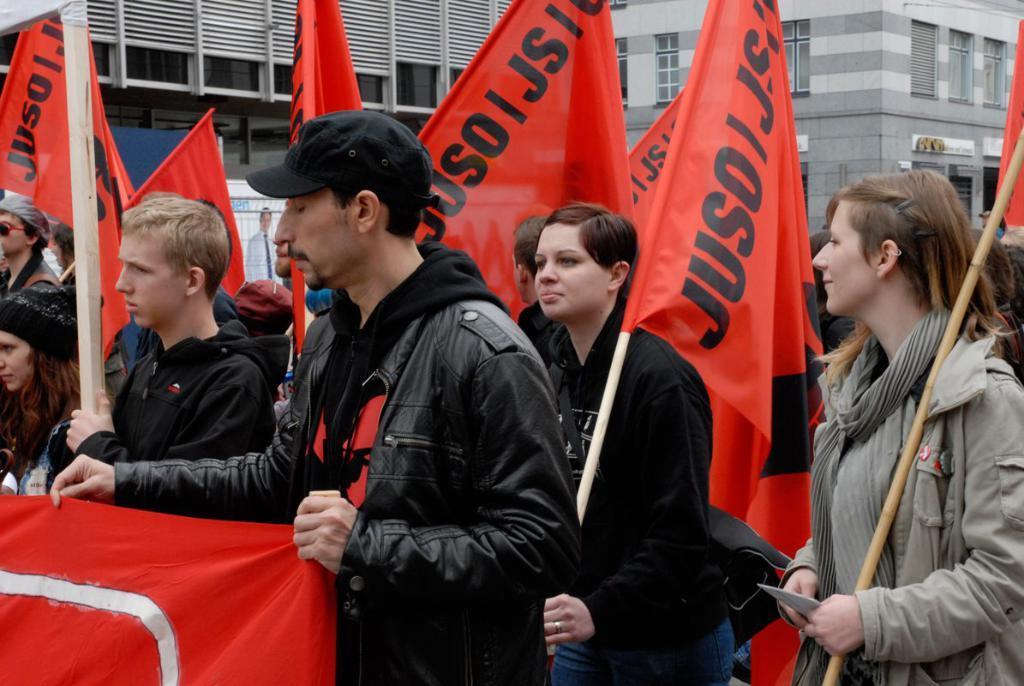Describe this image in one or two sentences. In this picture there is a man who is wearing cap, jacket, t-shirt and trouser. He is holding a red color cloth. On the right there are two women who are holding a flag. In the back we can see group of persons. On the top we can see buildings. Here we can see banner. 